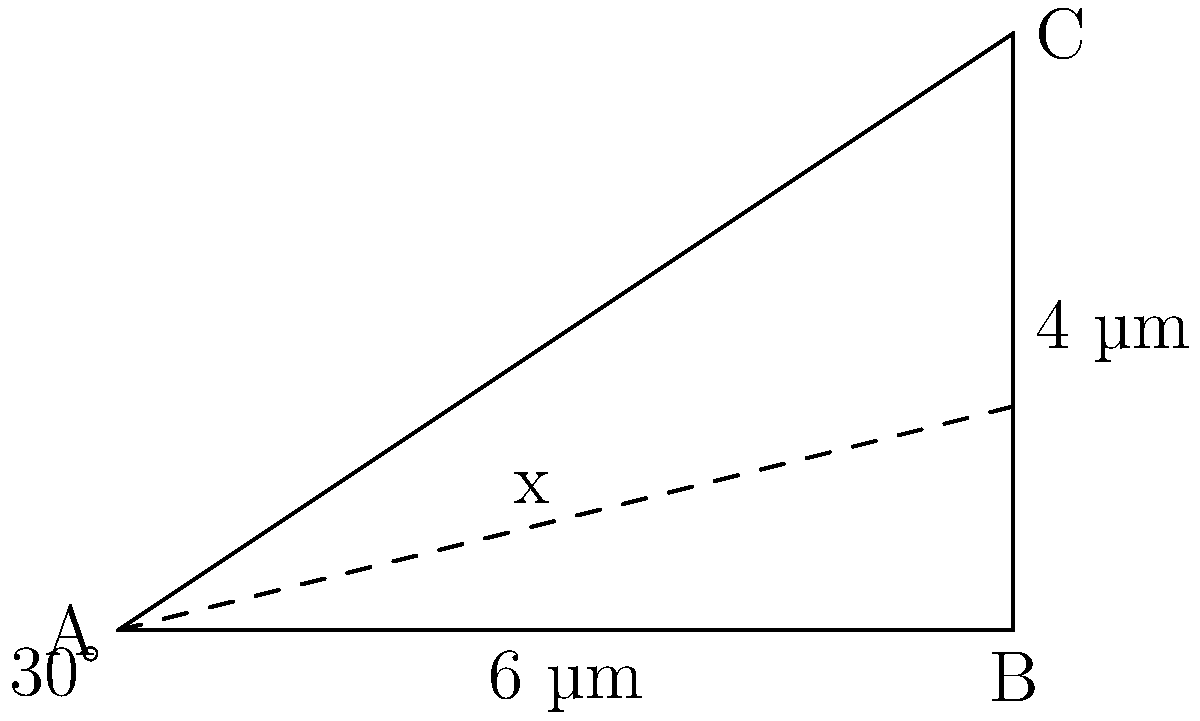In a microscopic examination of a neuron synapse, you observe a triangular structure. The base of this structure measures 6 µm, and it forms a 30° angle with the horizontal plane. The height of the structure is 4 µm. Using trigonometric ratios, calculate the distance (x) from the base of the triangle to the point where a perpendicular line from the apex meets the base. Let's approach this step-by-step:

1) First, we identify the trigonometric ratio we need to use. In this case, we're looking for the adjacent side of a right triangle where we know the hypotenuse and the angle. This calls for the cosine function.

2) The cosine of an angle in a right triangle is the ratio of the adjacent side to the hypotenuse. In our case:

   $\cos(30°) = \frac{x}{4}$

3) We know the value of $\cos(30°)$. It's $\frac{\sqrt{3}}{2}$.

4) Let's substitute this value:

   $\frac{\sqrt{3}}{2} = \frac{x}{4}$

5) Now, we can solve for x:

   $x = 4 \cdot \frac{\sqrt{3}}{2} = 2\sqrt{3}$

6) Therefore, the distance x is $2\sqrt{3}$ µm.

This calculation helps us understand the precise structure of the neuron synapse, which is crucial for cognitive therapy and rehabilitation.
Answer: $2\sqrt{3}$ µm 